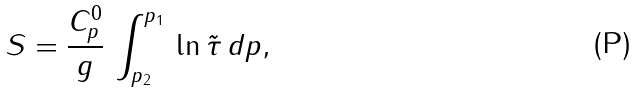<formula> <loc_0><loc_0><loc_500><loc_500>S = \frac { C _ { p } ^ { 0 } } { g } \, \int _ { p _ { 2 } } ^ { p _ { 1 } } \, \ln \tilde { \tau } \, d p ,</formula> 